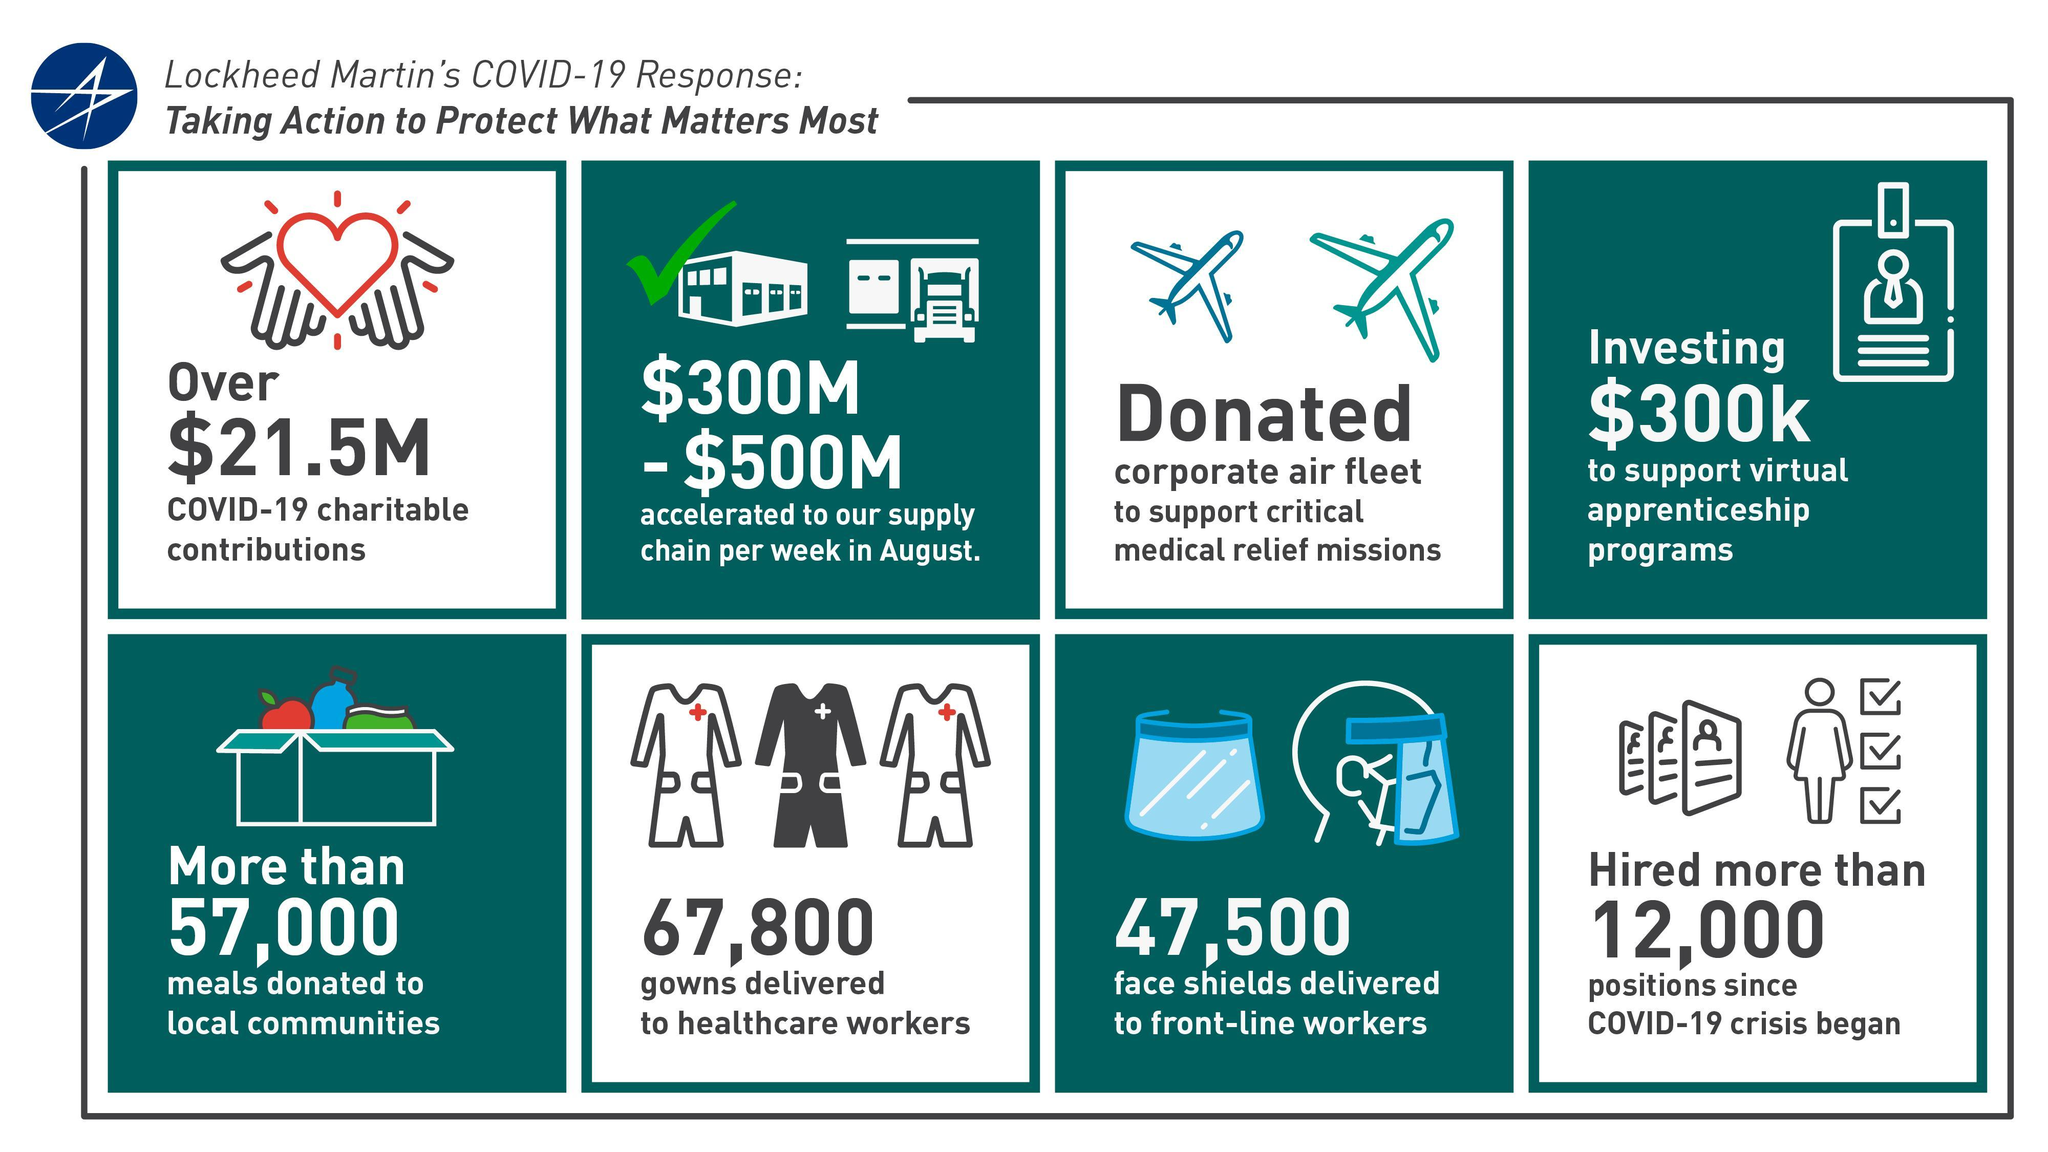How much money was given to support virtual apprenticeship programs?
Answer the question with a short phrase. $300k How many food packets were delivered to regional communities? more than 57,000 How many people were newly hired to overcome COVID-19 impact? more than 12,000 What is the initiative taken to provide urgent medical care? corporate air fleet How many face visors were given to battle-line workers? 47,500 How much money was donated to COVID-19 charity organizations? $21.5M How many dresses were shipped to medical staffs? 67,800 How much was the amount transferred to supply chain to meet Covid-19 crisis? $300M-$500M 